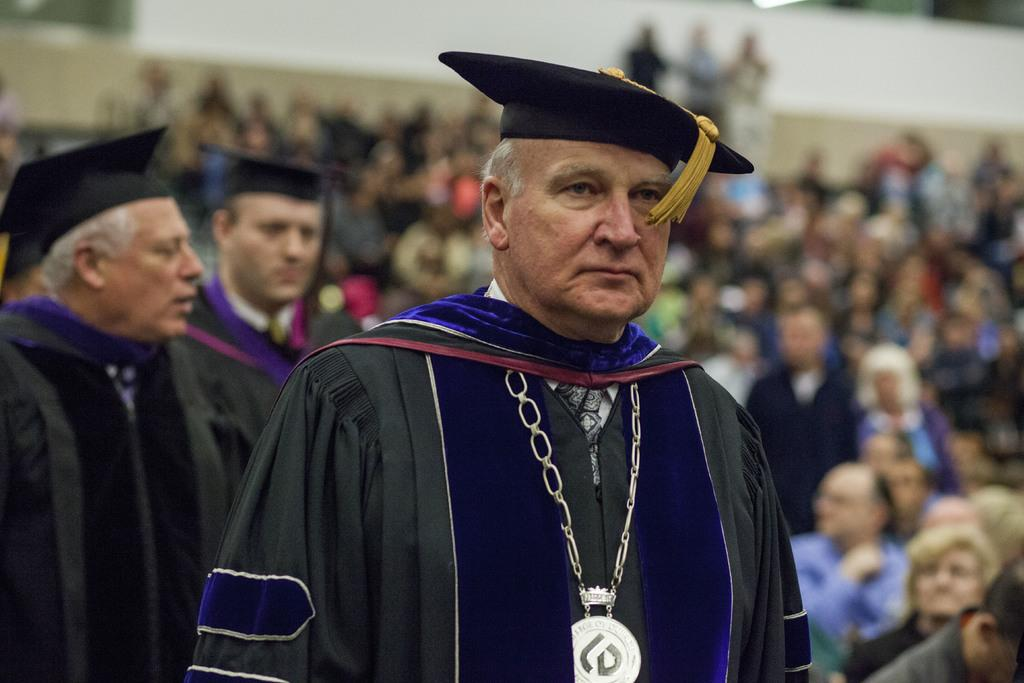What can be seen in the image? There are people standing in the image. What are the people wearing on their heads? The people are wearing caps. Can you describe the people in the background of the image? The people in the background are visible, but they are blurry. What is the income of the person standing next to the faucet in the image? There is no faucet present in the image, and therefore no information about the person's income can be determined. 